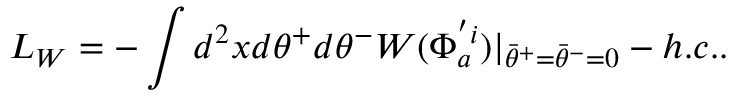<formula> <loc_0><loc_0><loc_500><loc_500>L _ { W } = - \int d ^ { 2 } x d \theta ^ { + } d \theta ^ { - } W ( \Phi _ { a } ^ { ^ { \prime } i } ) | _ { { \bar { \theta } } ^ { + } = { \bar { \theta } } ^ { - } = 0 } - h . c . .</formula> 